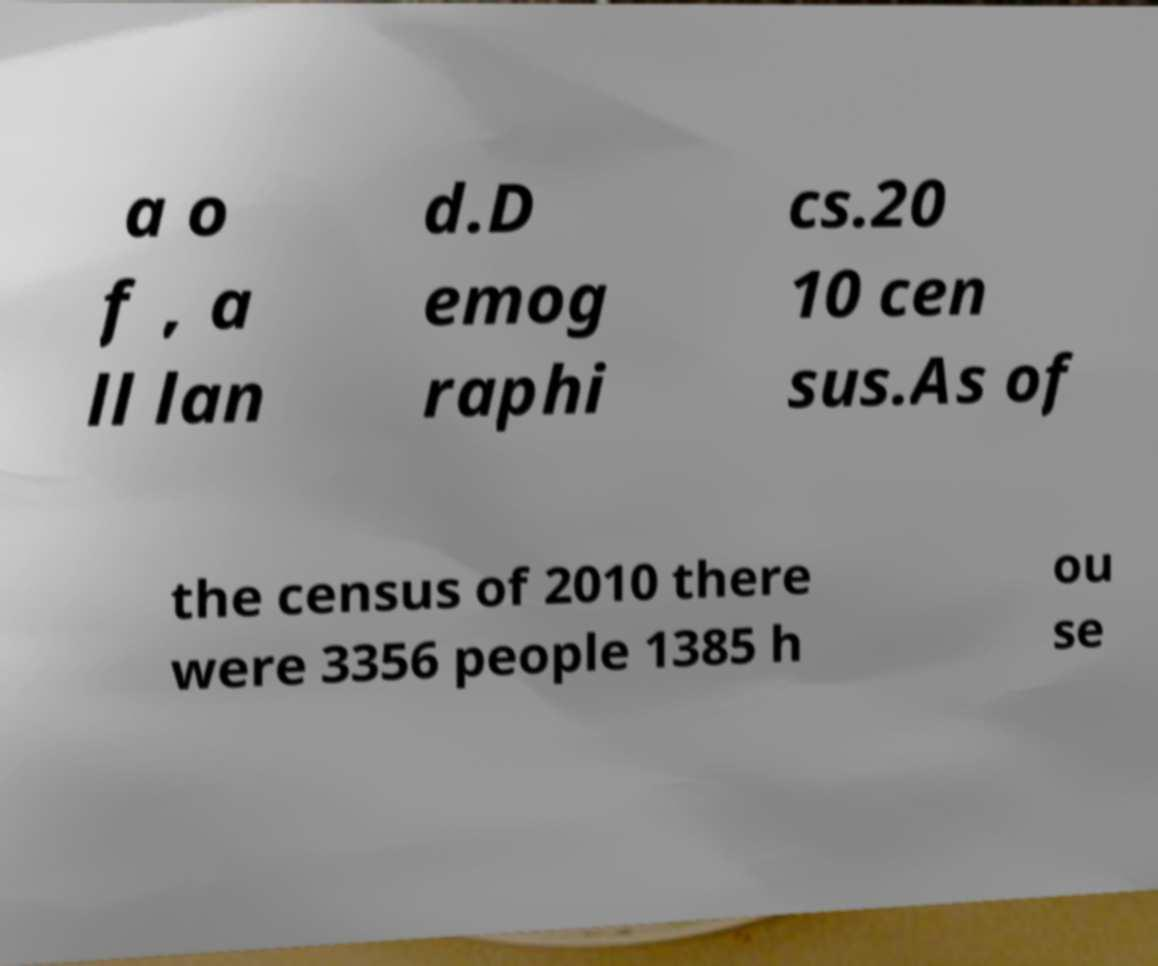There's text embedded in this image that I need extracted. Can you transcribe it verbatim? a o f , a ll lan d.D emog raphi cs.20 10 cen sus.As of the census of 2010 there were 3356 people 1385 h ou se 